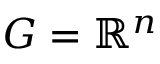<formula> <loc_0><loc_0><loc_500><loc_500>G = \mathbb { R } ^ { n }</formula> 